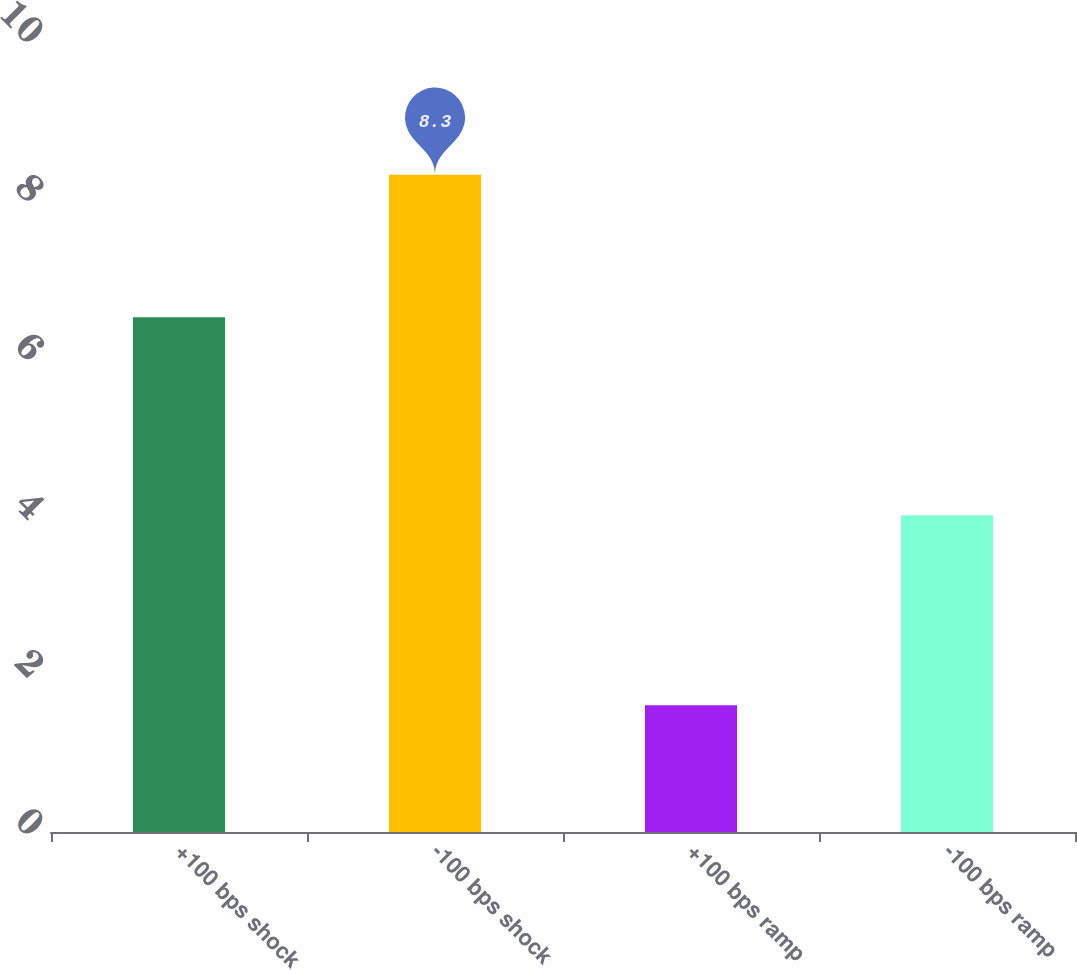Convert chart. <chart><loc_0><loc_0><loc_500><loc_500><bar_chart><fcel>+100 bps shock<fcel>-100 bps shock<fcel>+100 bps ramp<fcel>-100 bps ramp<nl><fcel>6.5<fcel>8.3<fcel>1.6<fcel>4<nl></chart> 